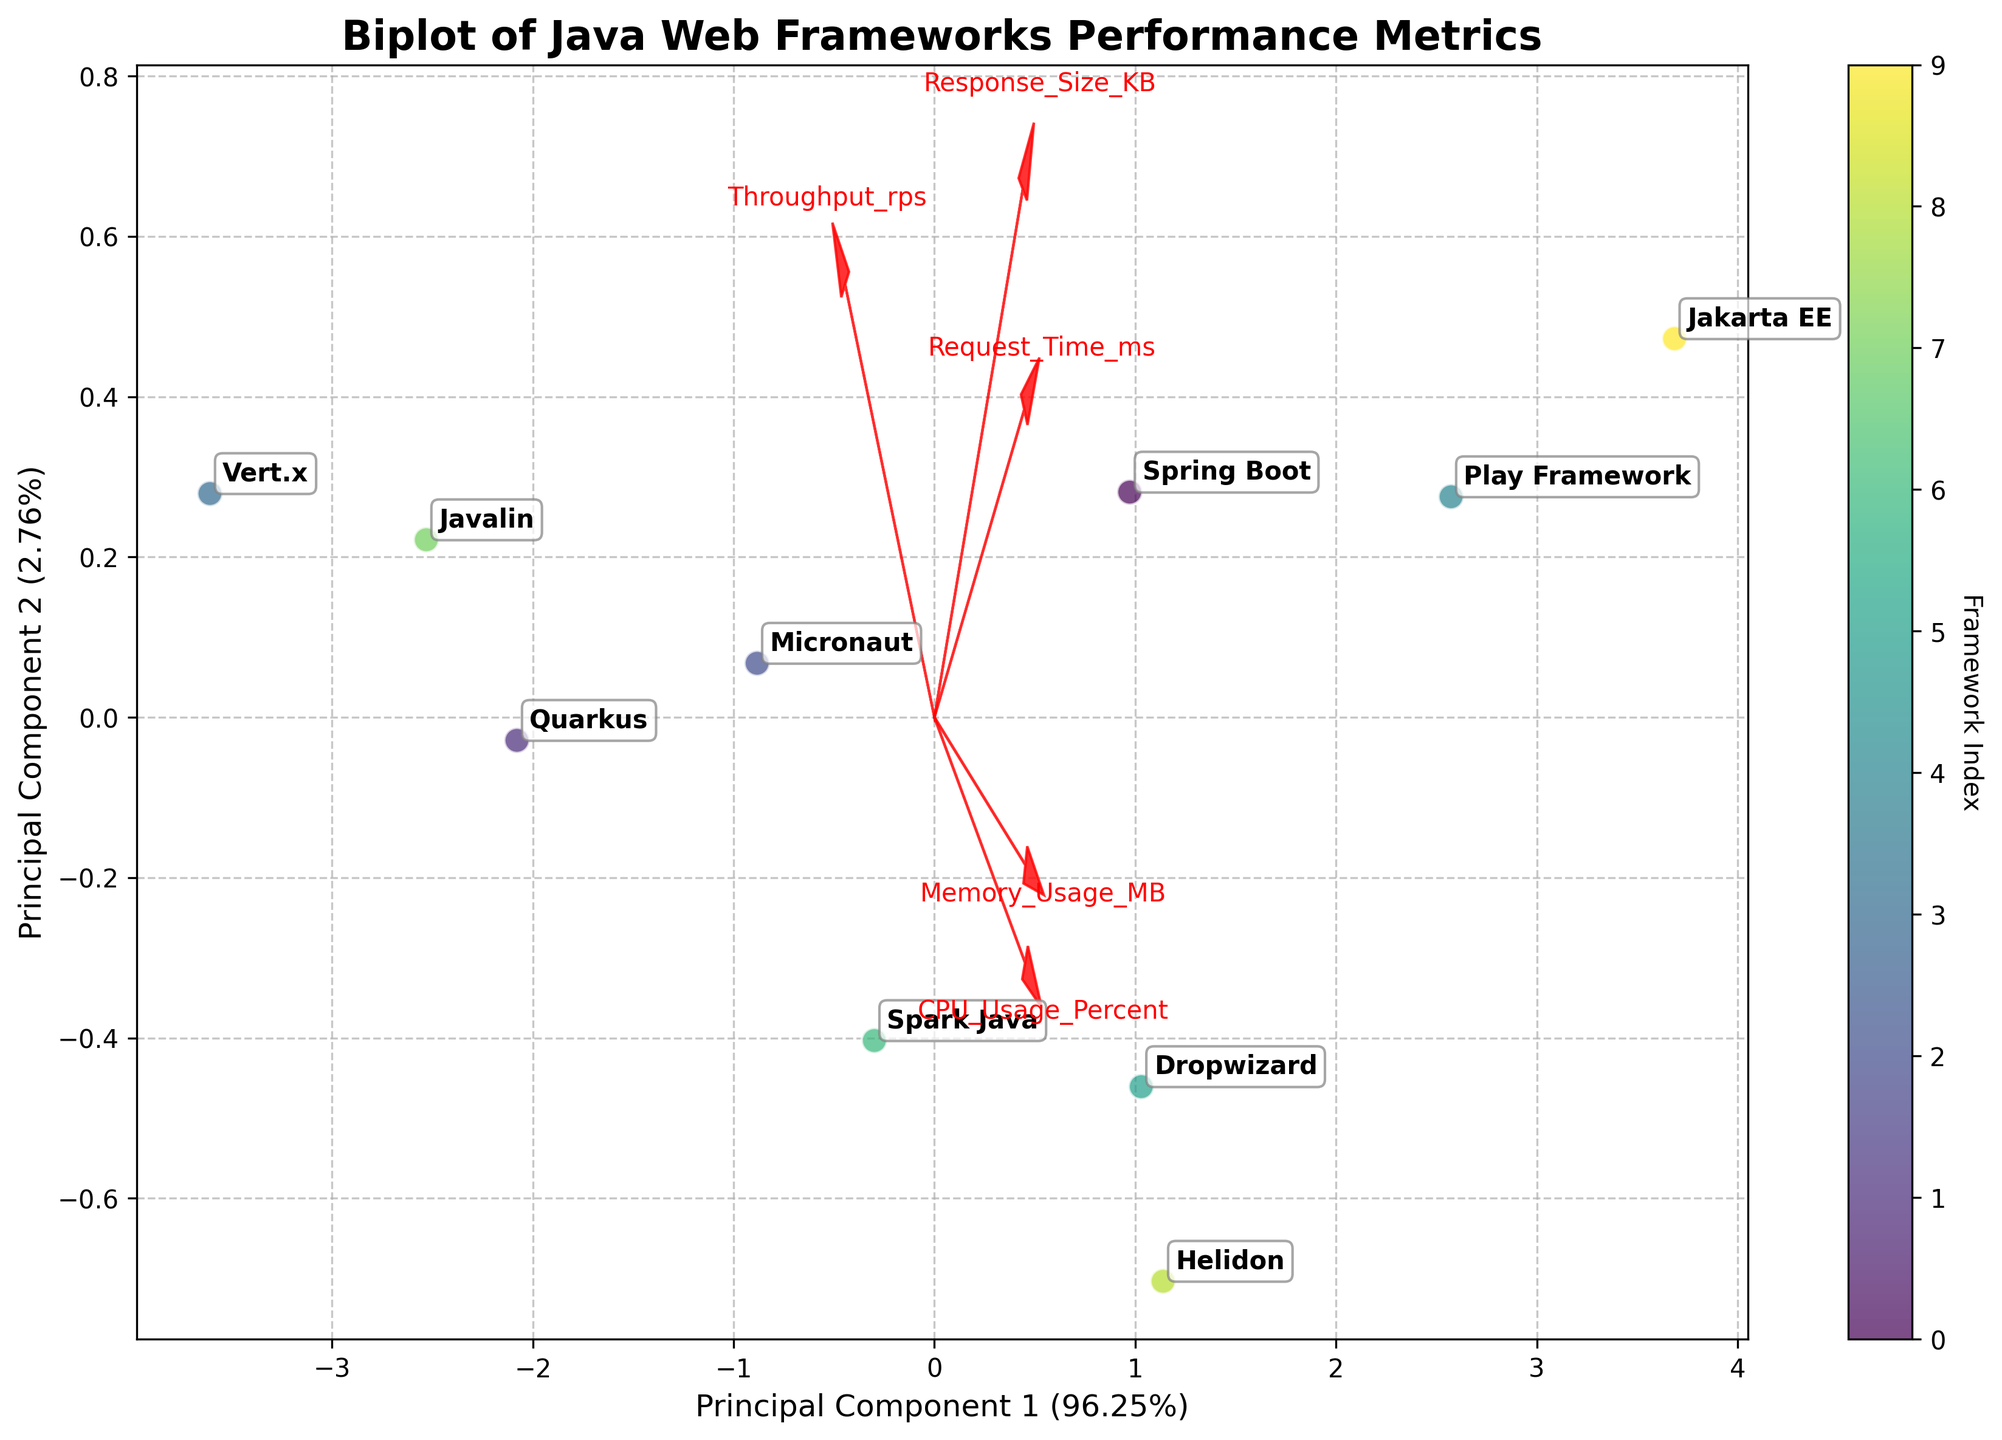What is the title of the figure? The title is displayed on top of the figure and summarizes what the biplot is about. The exact wording used is "Biplot of Java Web Frameworks Performance Metrics".
Answer: Biplot of Java Web Frameworks Performance Metrics How many Java frameworks are represented in the biplot? The number of data points plotted corresponds to the number of Java frameworks. Each framework is distinctly labeled.
Answer: 10 Which principal component explains more variance in the data? The x-axis represents Principal Component 1 (PC1) and the y-axis represents Principal Component 2 (PC2). The percentage of variance explained by each component is shown in the axis labels. By comparing these percentages, we see that PC1 has a higher percentage.
Answer: Principal Component 1 (PC1) Which Java framework has the highest coordinate along PC1? By looking at the positioning of data points along the x-axis (PC1), we identify the framework farthest to the right.
Answer: Play Framework Which framework is closest to the origin of the biplot? We identify the data point that is nearest to the intersection of the x and y axes, indicating the origin.
Answer: Javalin What does the direction of the "Throughput_rps" vector indicate? The direction and length of the vectors signify the relationship between the features and the principal components. The "Throughput_rps" vector, pointing predominantly to the right, indicates it is strongly aligned with PC1.
Answer: Strong alignment with PC1 Which feature has the least influence on PC1? By examining the length and direction of the vectors relative to PC1, the shortest vector in the horizontal direction corresponds to the feature with the least influence.
Answer: Response_Size_KB Which framework shows high "Throughput_rps" but low "Memory_Usage_MB"? The "Throughput_rps" vector points to higher values on PC1 while the "Memory_Usage_MB" vector points roughly in the opposite direction. We look for a framework placed far to the right but close to the bottom.
Answer: Vert.x How is the "CPU_Usage_Percent" vector oriented relative to the principal components? The orientation of the "CPU_Usage_Percent" vector, shown by its arrow direction, gives insight into its contribution. If it points diagonally, it affects both PC1 and PC2.
Answer: Diagonally towards top right Which frameworks are closely grouped together in terms of the performance metrics? We locate frameworks that cluster near one another, showing similar transformed scores on both PC1 and PC2.
Answer: Quarkus, Javalin, Vert.x 